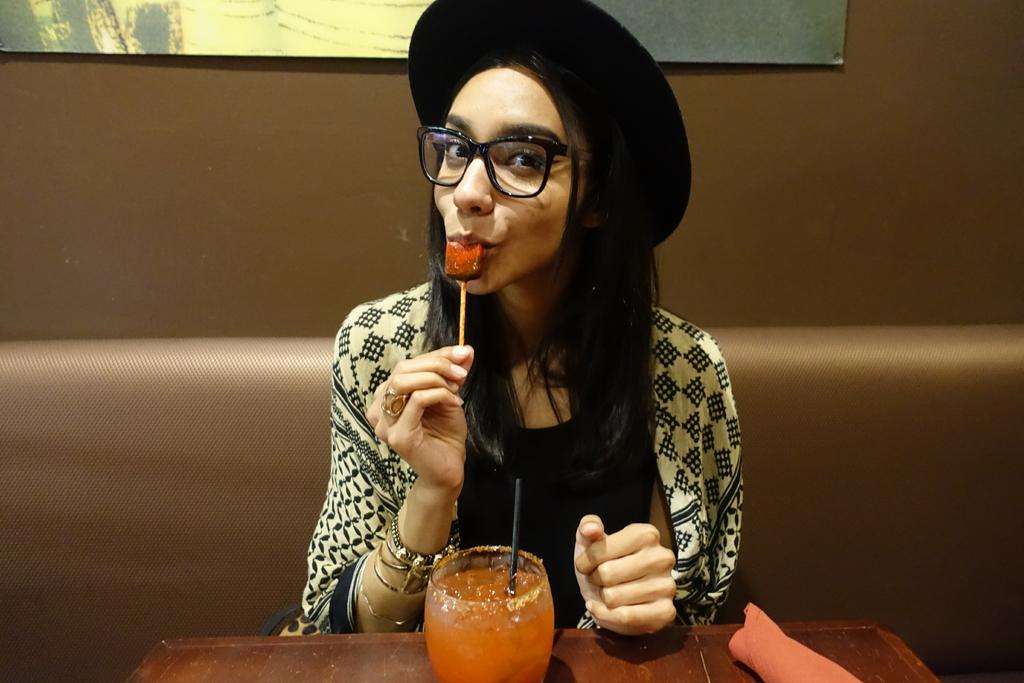What is the person in the image doing? The person is holding an ice cream bar. Where is the person sitting in relation to the table? The person is sitting in front of a table. What materials can be seen on the table in the image? The table contains glass and cloth. Can you describe the object at the top of the image? Unfortunately, the facts provided do not give any information about the object at the top of the image. What type of plastic is used to make the cart in the image? There is no cart present in the image, so it is not possible to determine what type of plastic might be used. 